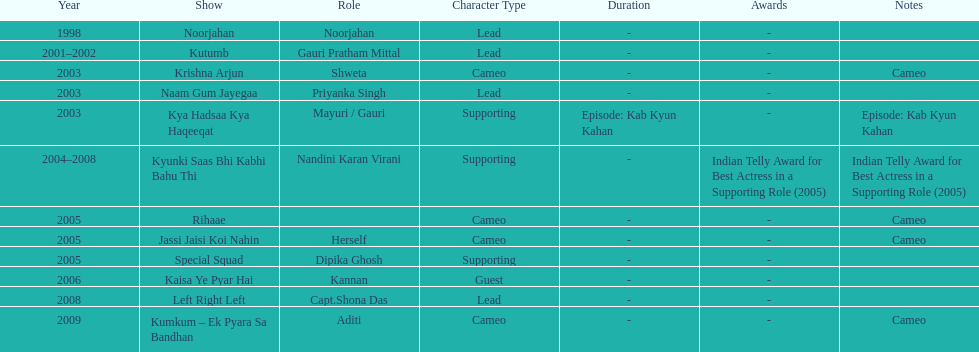How many total television shows has gauri starred in? 12. 